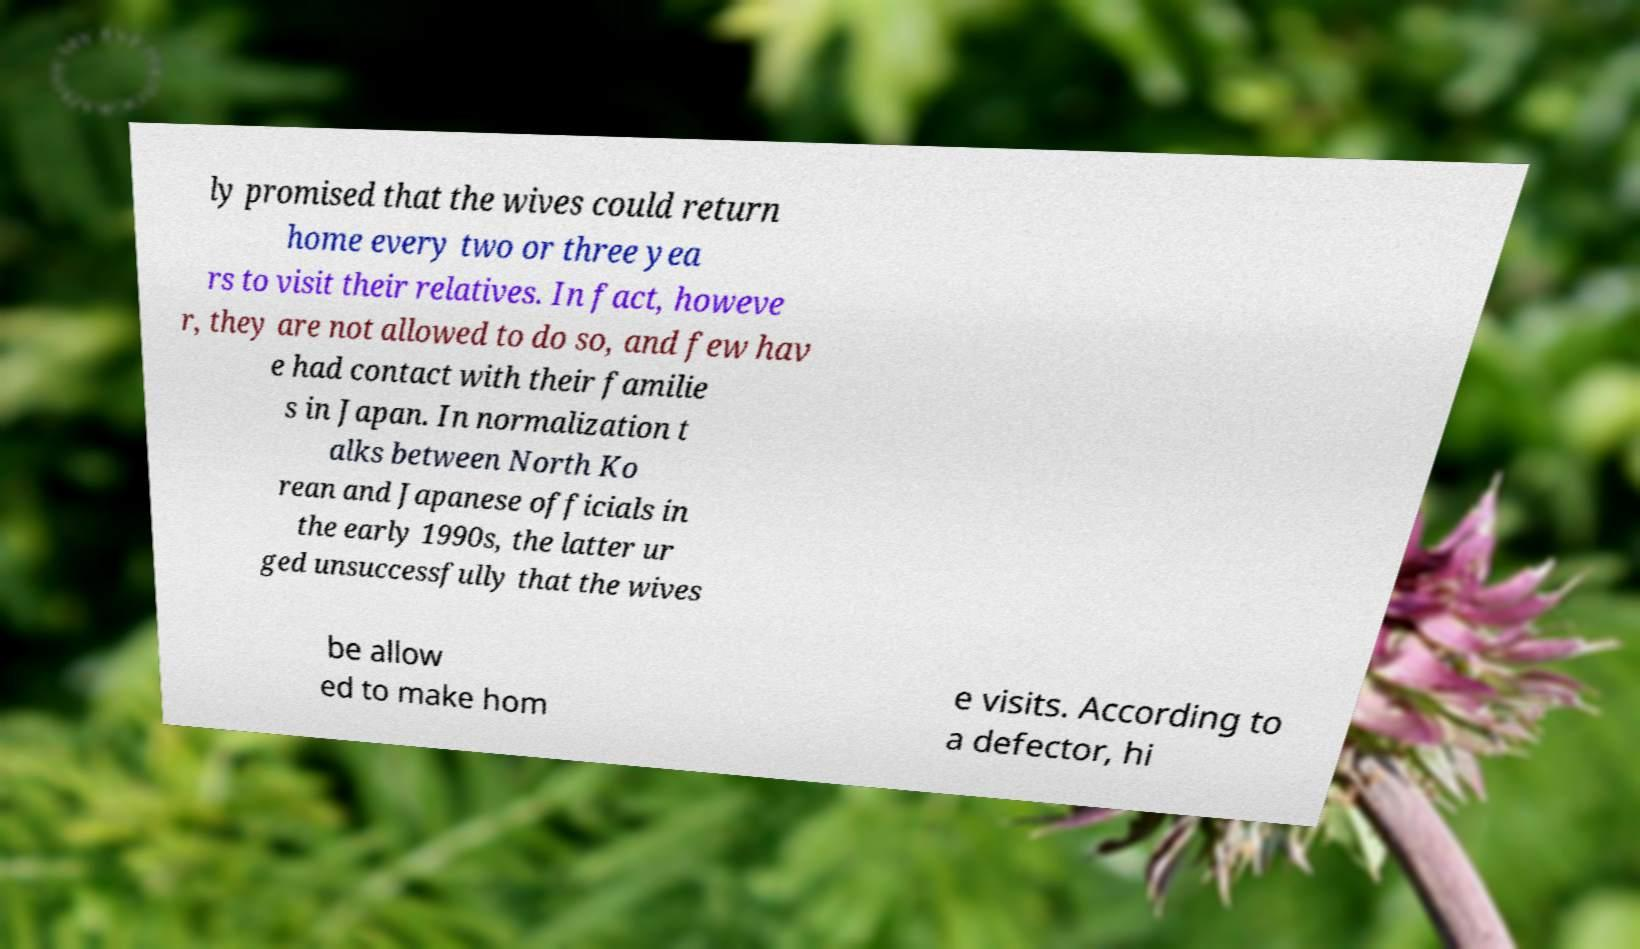What messages or text are displayed in this image? I need them in a readable, typed format. ly promised that the wives could return home every two or three yea rs to visit their relatives. In fact, howeve r, they are not allowed to do so, and few hav e had contact with their familie s in Japan. In normalization t alks between North Ko rean and Japanese officials in the early 1990s, the latter ur ged unsuccessfully that the wives be allow ed to make hom e visits. According to a defector, hi 